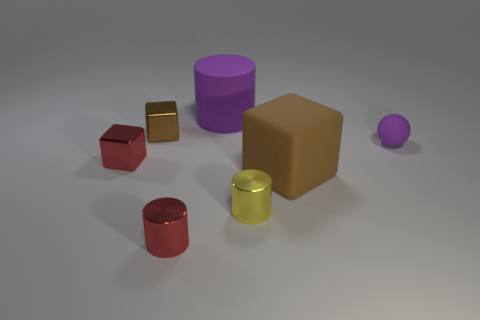How many other objects are the same shape as the yellow shiny object?
Offer a very short reply. 2. There is a purple sphere that is on the right side of the red thing that is to the right of the tiny thing behind the purple ball; what size is it?
Provide a short and direct response. Small. What number of purple objects are small matte spheres or large rubber blocks?
Your answer should be very brief. 1. There is a purple rubber thing that is behind the thing right of the big brown block; what shape is it?
Ensure brevity in your answer.  Cylinder. Is the size of the metal cylinder on the right side of the purple cylinder the same as the metallic thing behind the small matte sphere?
Keep it short and to the point. Yes. Are there any tiny cylinders that have the same material as the small brown cube?
Give a very brief answer. Yes. The metallic cube that is the same color as the matte block is what size?
Ensure brevity in your answer.  Small. There is a purple object on the right side of the big object in front of the small purple matte thing; are there any shiny cubes that are in front of it?
Your response must be concise. Yes. Are there any matte things behind the tiny red shiny cube?
Offer a terse response. Yes. How many small red shiny cubes are on the right side of the red block in front of the purple cylinder?
Your answer should be compact. 0. 